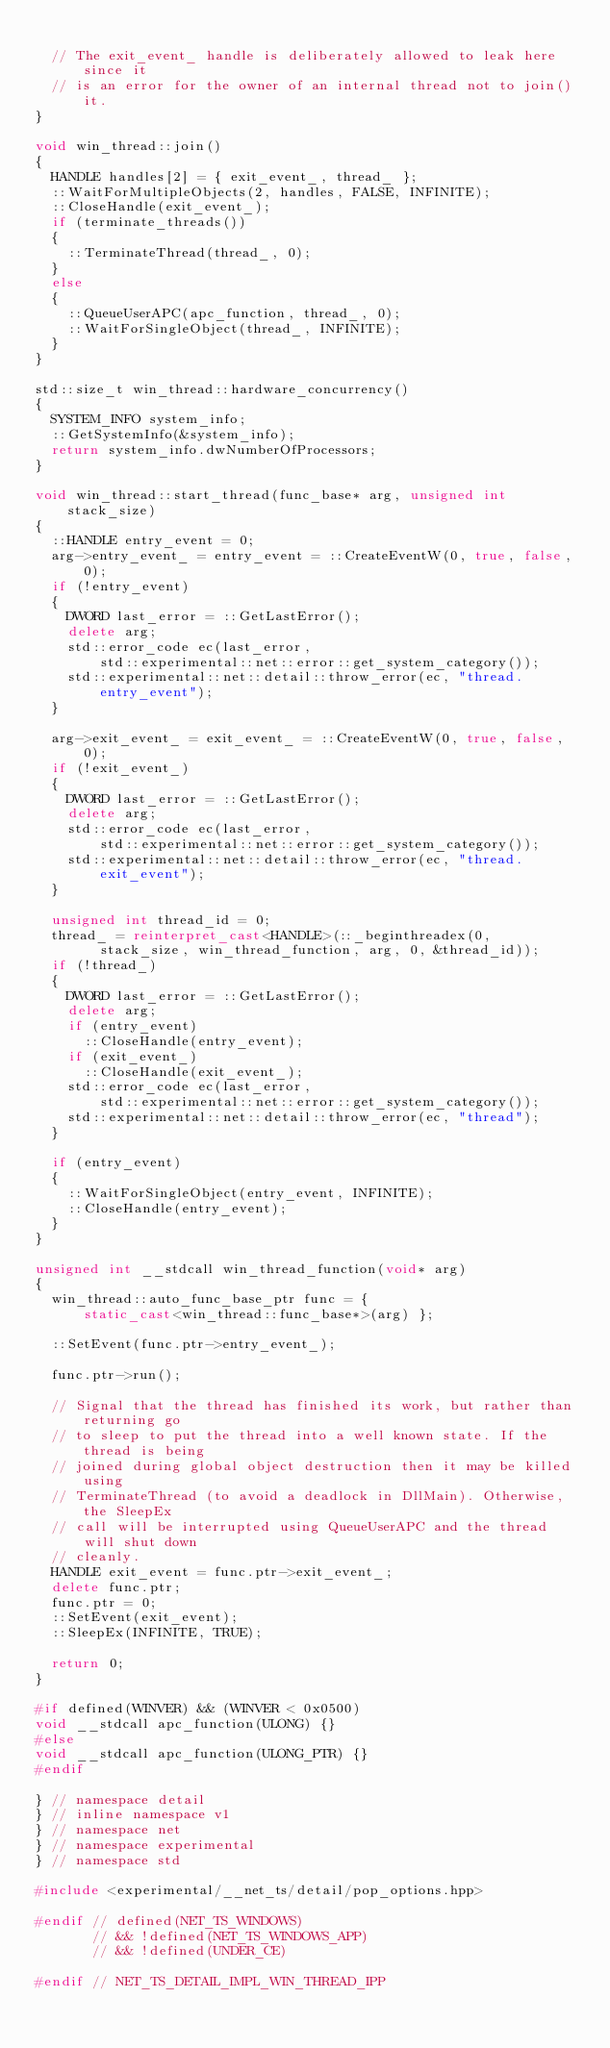Convert code to text. <code><loc_0><loc_0><loc_500><loc_500><_C++_>
  // The exit_event_ handle is deliberately allowed to leak here since it
  // is an error for the owner of an internal thread not to join() it.
}

void win_thread::join()
{
  HANDLE handles[2] = { exit_event_, thread_ };
  ::WaitForMultipleObjects(2, handles, FALSE, INFINITE);
  ::CloseHandle(exit_event_);
  if (terminate_threads())
  {
    ::TerminateThread(thread_, 0);
  }
  else
  {
    ::QueueUserAPC(apc_function, thread_, 0);
    ::WaitForSingleObject(thread_, INFINITE);
  }
}

std::size_t win_thread::hardware_concurrency()
{
  SYSTEM_INFO system_info;
  ::GetSystemInfo(&system_info);
  return system_info.dwNumberOfProcessors;
}

void win_thread::start_thread(func_base* arg, unsigned int stack_size)
{
  ::HANDLE entry_event = 0;
  arg->entry_event_ = entry_event = ::CreateEventW(0, true, false, 0);
  if (!entry_event)
  {
    DWORD last_error = ::GetLastError();
    delete arg;
    std::error_code ec(last_error,
        std::experimental::net::error::get_system_category());
    std::experimental::net::detail::throw_error(ec, "thread.entry_event");
  }

  arg->exit_event_ = exit_event_ = ::CreateEventW(0, true, false, 0);
  if (!exit_event_)
  {
    DWORD last_error = ::GetLastError();
    delete arg;
    std::error_code ec(last_error,
        std::experimental::net::error::get_system_category());
    std::experimental::net::detail::throw_error(ec, "thread.exit_event");
  }

  unsigned int thread_id = 0;
  thread_ = reinterpret_cast<HANDLE>(::_beginthreadex(0,
        stack_size, win_thread_function, arg, 0, &thread_id));
  if (!thread_)
  {
    DWORD last_error = ::GetLastError();
    delete arg;
    if (entry_event)
      ::CloseHandle(entry_event);
    if (exit_event_)
      ::CloseHandle(exit_event_);
    std::error_code ec(last_error,
        std::experimental::net::error::get_system_category());
    std::experimental::net::detail::throw_error(ec, "thread");
  }

  if (entry_event)
  {
    ::WaitForSingleObject(entry_event, INFINITE);
    ::CloseHandle(entry_event);
  }
}

unsigned int __stdcall win_thread_function(void* arg)
{
  win_thread::auto_func_base_ptr func = {
      static_cast<win_thread::func_base*>(arg) };

  ::SetEvent(func.ptr->entry_event_);

  func.ptr->run();

  // Signal that the thread has finished its work, but rather than returning go
  // to sleep to put the thread into a well known state. If the thread is being
  // joined during global object destruction then it may be killed using
  // TerminateThread (to avoid a deadlock in DllMain). Otherwise, the SleepEx
  // call will be interrupted using QueueUserAPC and the thread will shut down
  // cleanly.
  HANDLE exit_event = func.ptr->exit_event_;
  delete func.ptr;
  func.ptr = 0;
  ::SetEvent(exit_event);
  ::SleepEx(INFINITE, TRUE);

  return 0;
}

#if defined(WINVER) && (WINVER < 0x0500)
void __stdcall apc_function(ULONG) {}
#else
void __stdcall apc_function(ULONG_PTR) {}
#endif

} // namespace detail
} // inline namespace v1
} // namespace net
} // namespace experimental
} // namespace std

#include <experimental/__net_ts/detail/pop_options.hpp>

#endif // defined(NET_TS_WINDOWS)
       // && !defined(NET_TS_WINDOWS_APP)
       // && !defined(UNDER_CE)

#endif // NET_TS_DETAIL_IMPL_WIN_THREAD_IPP
</code> 